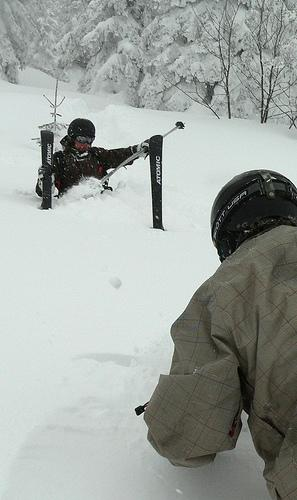How many person can be seen? Please explain your reasoning. two. There are two different people in the image. one looking forward and one looking back. 